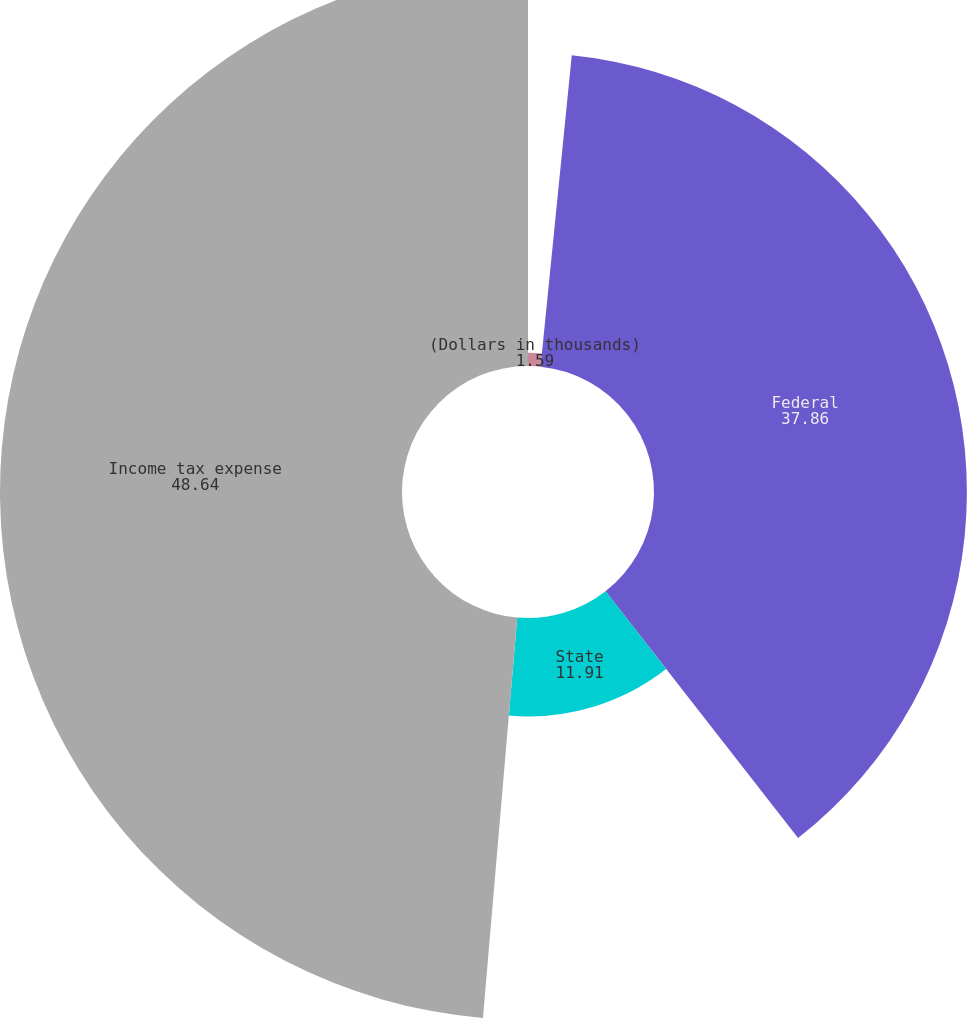Convert chart to OTSL. <chart><loc_0><loc_0><loc_500><loc_500><pie_chart><fcel>(Dollars in thousands)<fcel>Federal<fcel>State<fcel>Income tax expense<nl><fcel>1.59%<fcel>37.86%<fcel>11.91%<fcel>48.64%<nl></chart> 